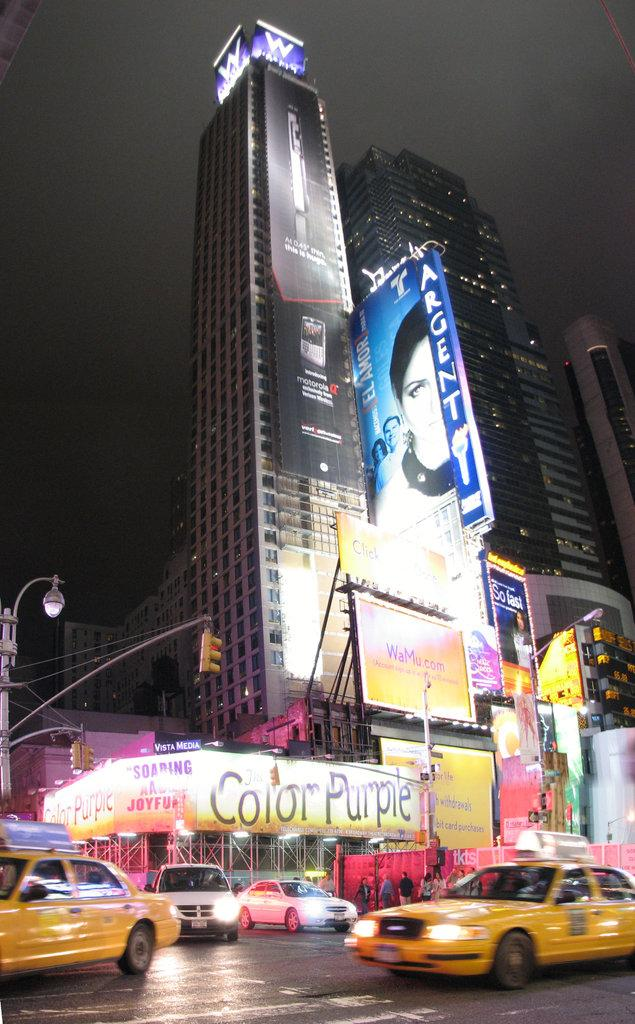<image>
Provide a brief description of the given image. A couple of taxis are driving through an intersection where Color Purple is advertised on a large banner. 